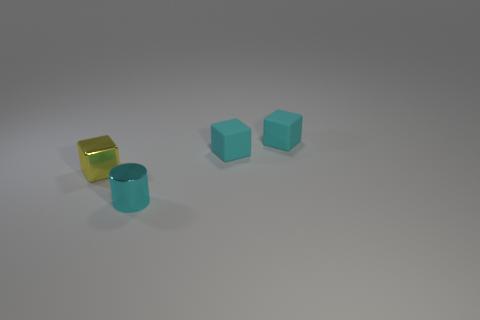Add 2 tiny yellow shiny things. How many objects exist? 6 Subtract all cylinders. How many objects are left? 3 Subtract all cyan cubes. How many cubes are left? 1 Subtract all tiny cyan blocks. How many blocks are left? 1 Subtract 0 purple blocks. How many objects are left? 4 Subtract 2 cubes. How many cubes are left? 1 Subtract all purple cubes. Subtract all green spheres. How many cubes are left? 3 Subtract all yellow blocks. How many blue cylinders are left? 0 Subtract all things. Subtract all small blue cylinders. How many objects are left? 0 Add 1 cyan metal cylinders. How many cyan metal cylinders are left? 2 